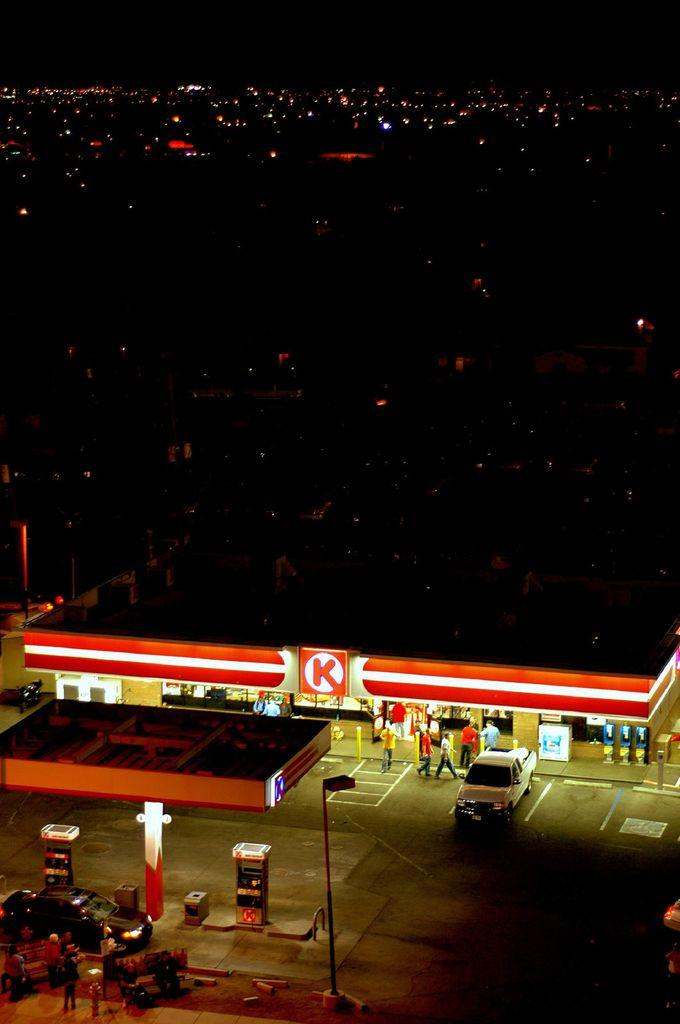<image>
Summarize the visual content of the image. Photo of Circle K gas station at night, taken from above. 